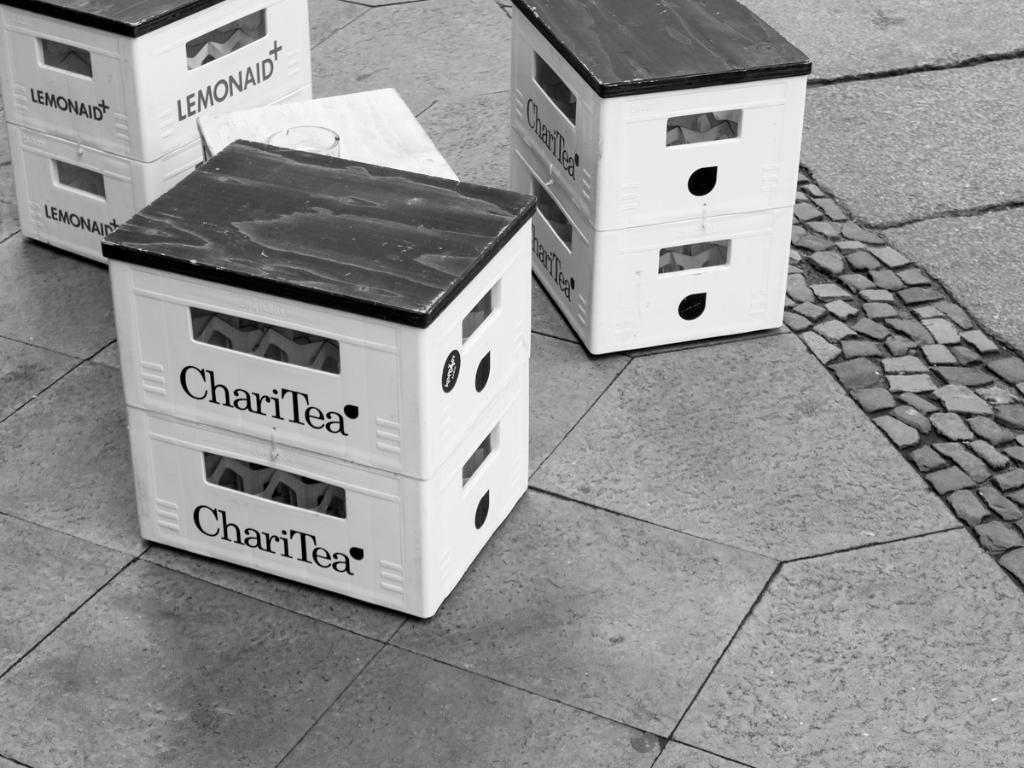<image>
Create a compact narrative representing the image presented. Three white boxes laying on floor tile that say Chari Tea. 